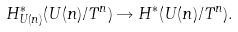Convert formula to latex. <formula><loc_0><loc_0><loc_500><loc_500>H _ { U ( n ) } ^ { \ast } ( U ( n ) / T ^ { n } ) \rightarrow H ^ { \ast } ( U ( n ) / T ^ { n } ) .</formula> 